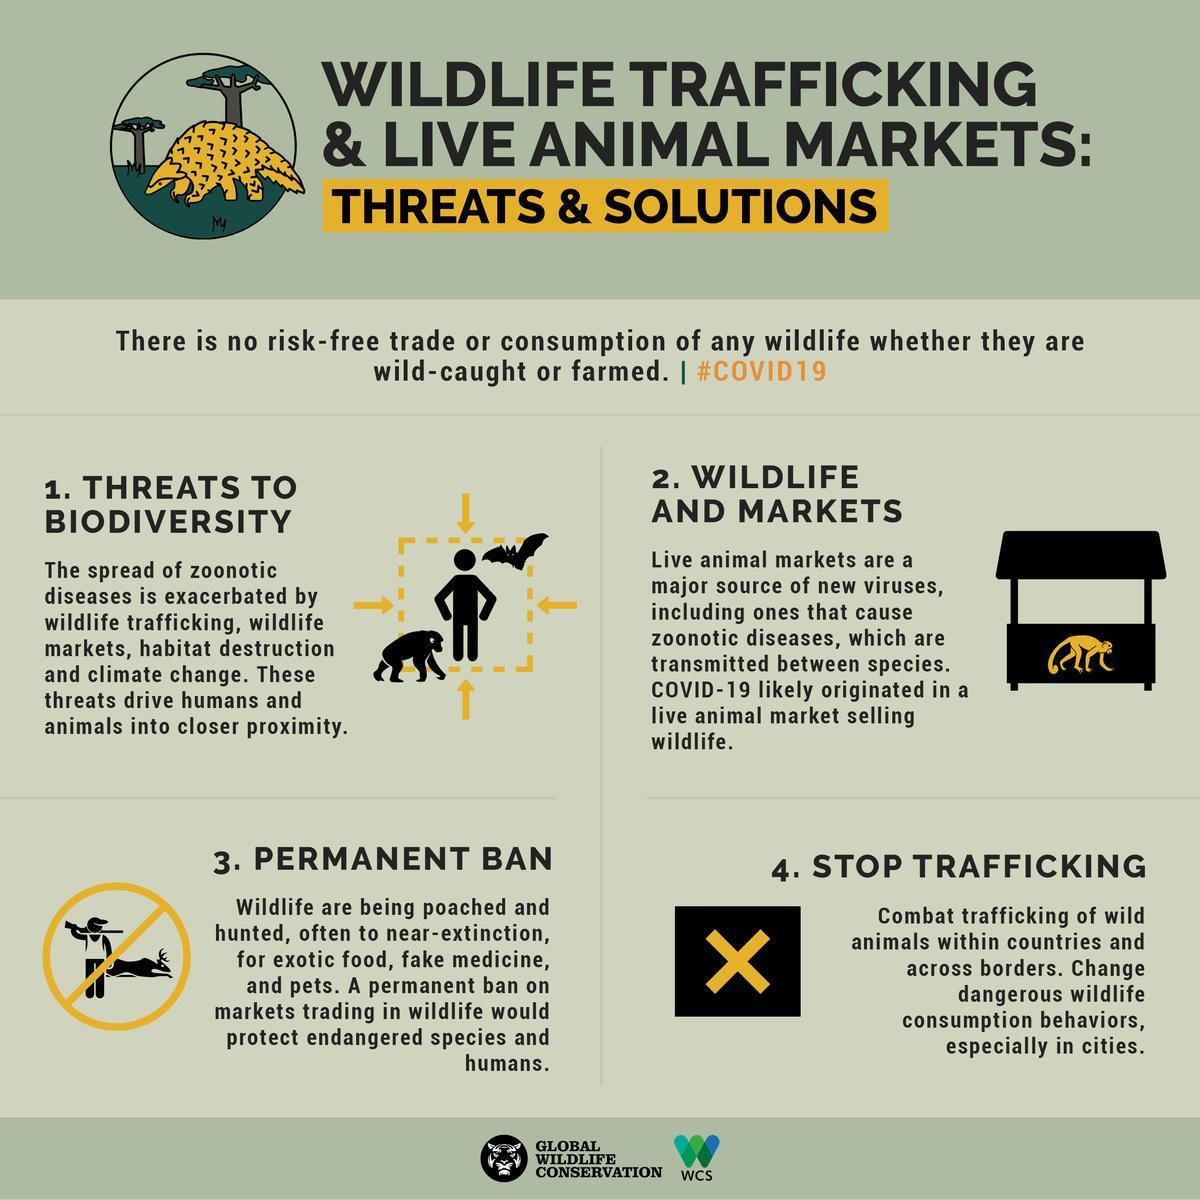What is the name of the disease that is transmitted between species?
Answer the question with a short phrase. zoonotic diseases 